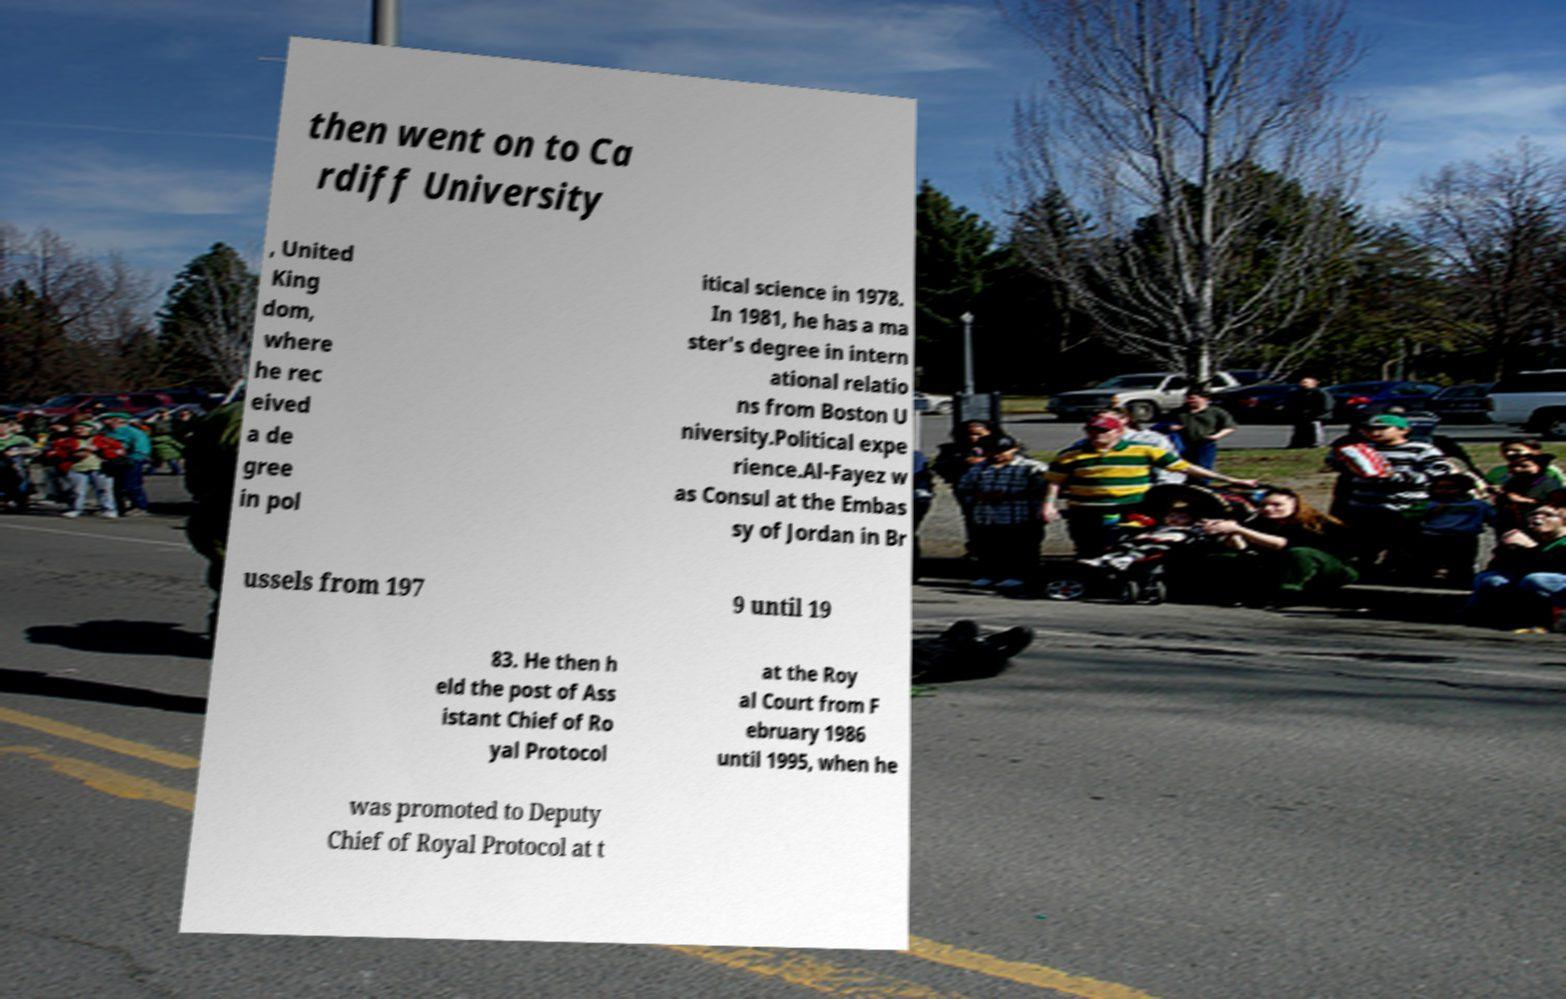Can you accurately transcribe the text from the provided image for me? then went on to Ca rdiff University , United King dom, where he rec eived a de gree in pol itical science in 1978. In 1981, he has a ma ster's degree in intern ational relatio ns from Boston U niversity.Political expe rience.Al-Fayez w as Consul at the Embas sy of Jordan in Br ussels from 197 9 until 19 83. He then h eld the post of Ass istant Chief of Ro yal Protocol at the Roy al Court from F ebruary 1986 until 1995, when he was promoted to Deputy Chief of Royal Protocol at t 